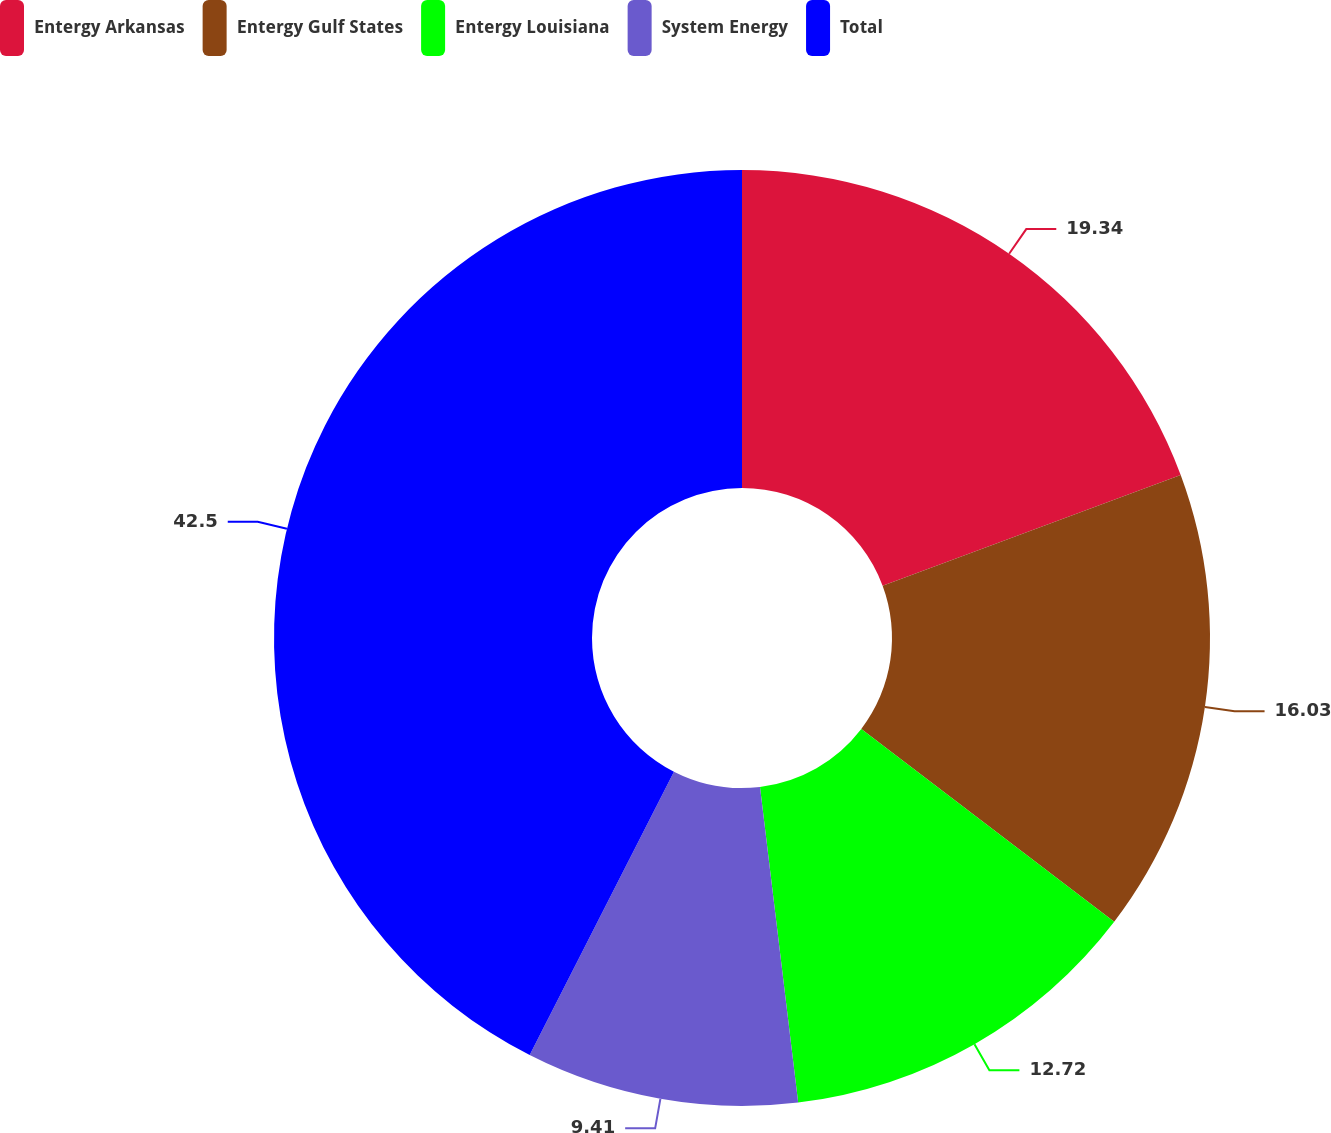Convert chart. <chart><loc_0><loc_0><loc_500><loc_500><pie_chart><fcel>Entergy Arkansas<fcel>Entergy Gulf States<fcel>Entergy Louisiana<fcel>System Energy<fcel>Total<nl><fcel>19.34%<fcel>16.03%<fcel>12.72%<fcel>9.41%<fcel>42.51%<nl></chart> 